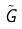Convert formula to latex. <formula><loc_0><loc_0><loc_500><loc_500>\tilde { G }</formula> 